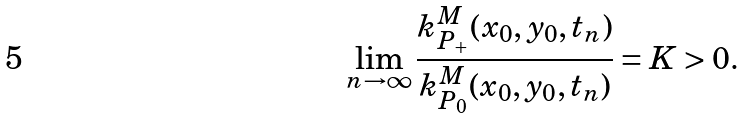<formula> <loc_0><loc_0><loc_500><loc_500>\lim _ { n \to \infty } \frac { k _ { P _ { + } } ^ { M } ( x _ { 0 } , y _ { 0 } , t _ { n } ) } { k _ { P _ { 0 } } ^ { M } ( x _ { 0 } , y _ { 0 } , t _ { n } ) } = K > 0 .</formula> 